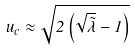<formula> <loc_0><loc_0><loc_500><loc_500>\, u _ { c } \approx \sqrt { 2 \left ( \sqrt { \tilde { \lambda } } - 1 \right ) }</formula> 